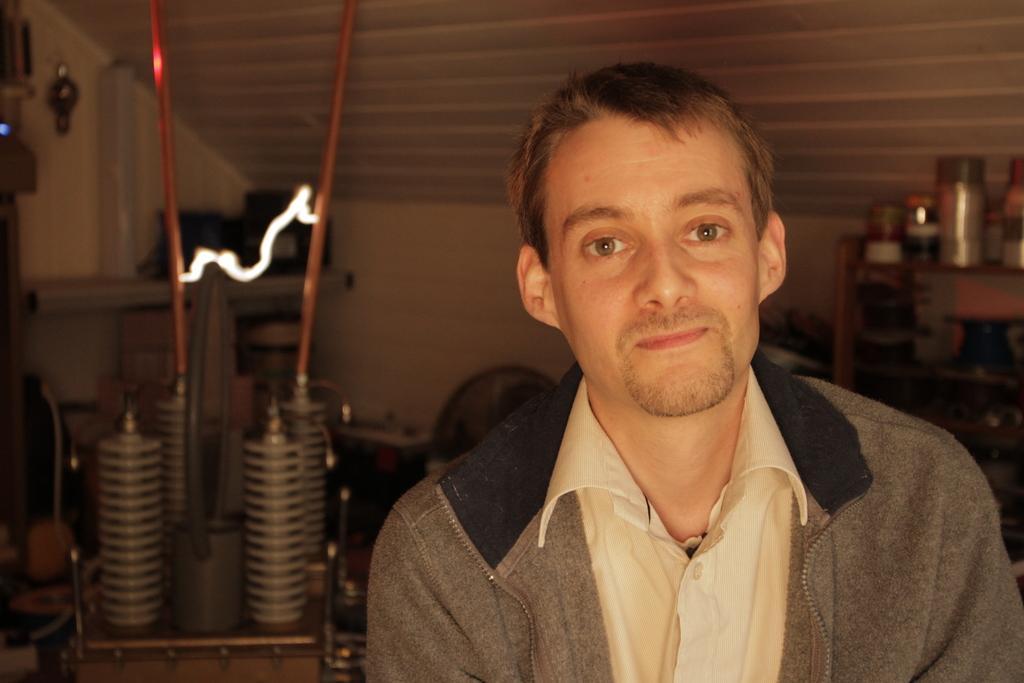Can you describe this image briefly? In this image in the foreground we can see a person and on the left side we can see some electric equipment and in the background we can see the roof. 